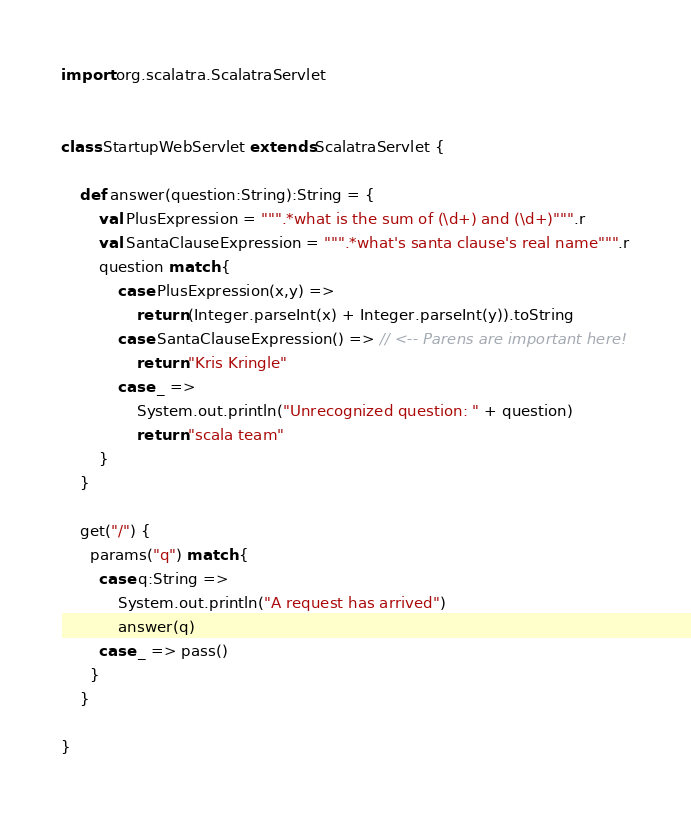<code> <loc_0><loc_0><loc_500><loc_500><_Scala_>import org.scalatra.ScalatraServlet


class StartupWebServlet extends ScalatraServlet {

    def answer(question:String):String = {
        val PlusExpression = """.*what is the sum of (\d+) and (\d+)""".r
        val SantaClauseExpression = """.*what's santa clause's real name""".r
        question match {
            case PlusExpression(x,y) =>
                return (Integer.parseInt(x) + Integer.parseInt(y)).toString
            case SantaClauseExpression() => // <-- Parens are important here!
                return "Kris Kringle"
            case _ =>
                System.out.println("Unrecognized question: " + question)
                return "scala team"
        }
    }

    get("/") {
      params("q") match {
        case q:String =>
            System.out.println("A request has arrived")
            answer(q)
        case _ => pass()
      }
    }

}
</code> 